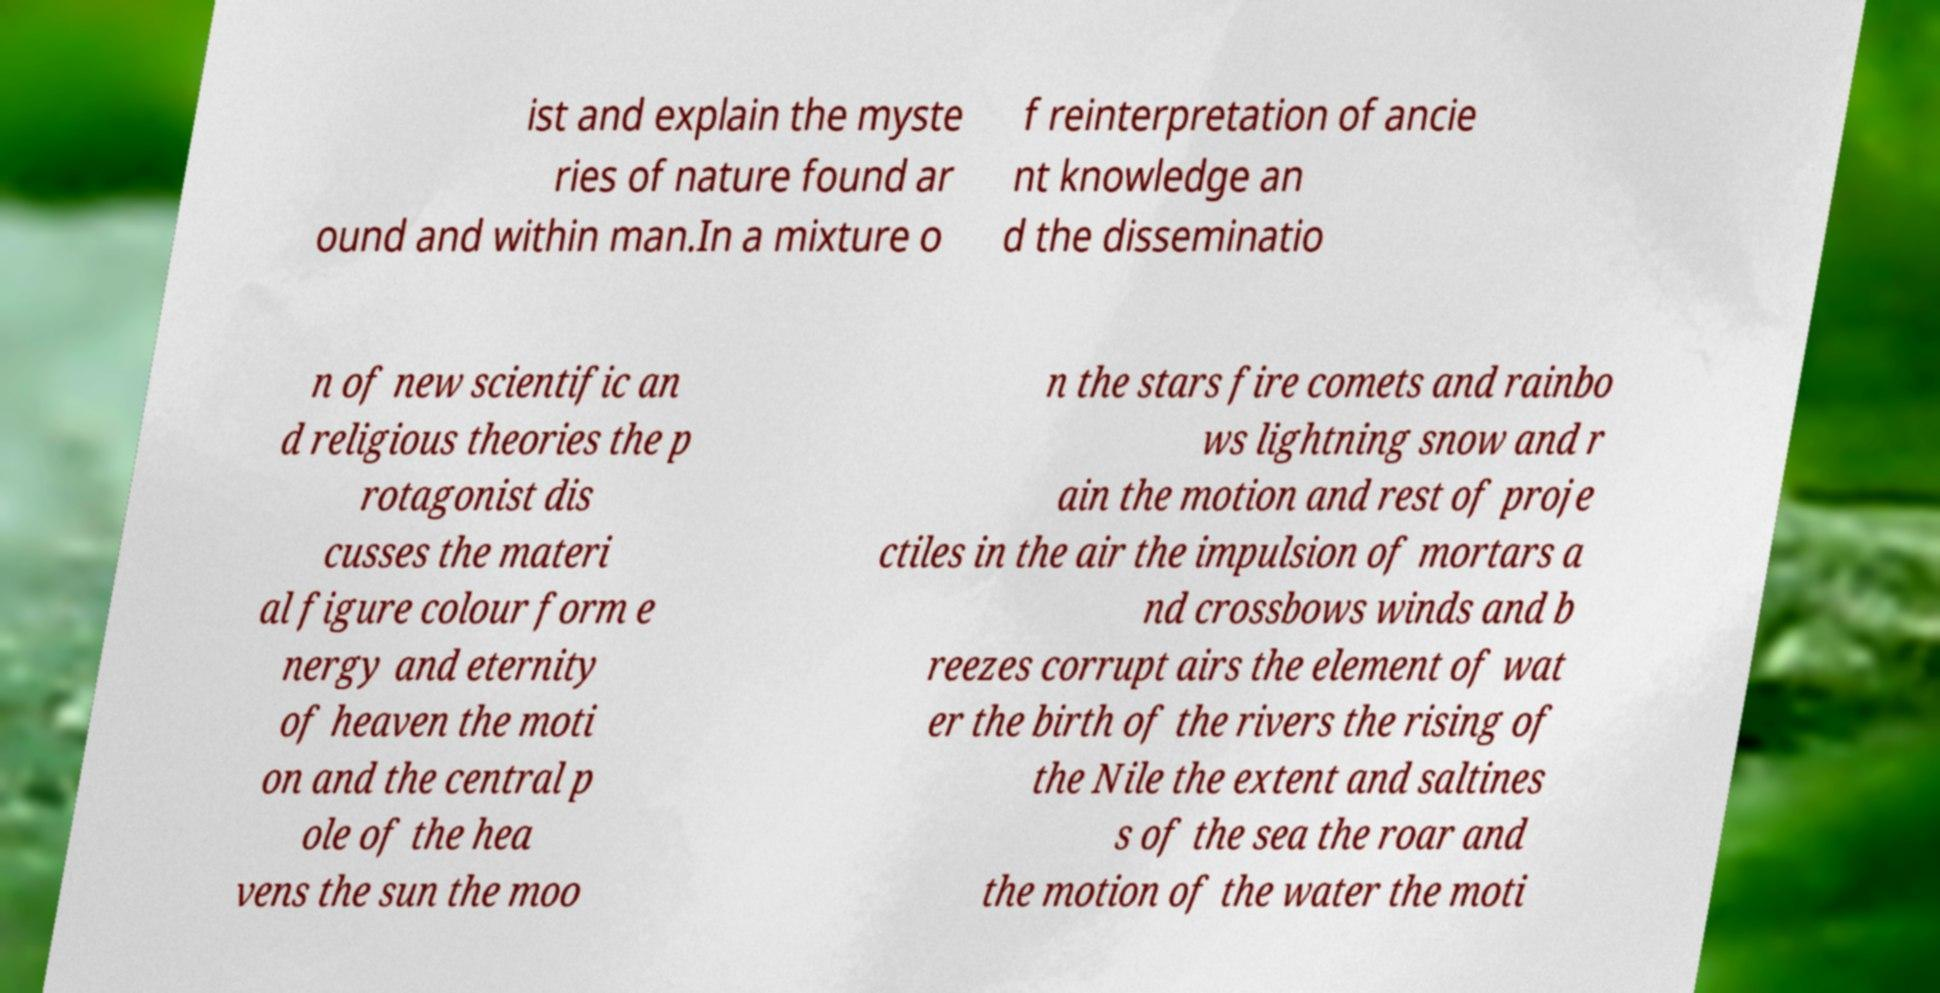Can you read and provide the text displayed in the image?This photo seems to have some interesting text. Can you extract and type it out for me? ist and explain the myste ries of nature found ar ound and within man.In a mixture o f reinterpretation of ancie nt knowledge an d the disseminatio n of new scientific an d religious theories the p rotagonist dis cusses the materi al figure colour form e nergy and eternity of heaven the moti on and the central p ole of the hea vens the sun the moo n the stars fire comets and rainbo ws lightning snow and r ain the motion and rest of proje ctiles in the air the impulsion of mortars a nd crossbows winds and b reezes corrupt airs the element of wat er the birth of the rivers the rising of the Nile the extent and saltines s of the sea the roar and the motion of the water the moti 